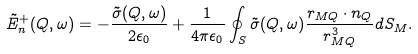Convert formula to latex. <formula><loc_0><loc_0><loc_500><loc_500>\tilde { E } _ { n } ^ { + } ( Q , \omega ) = - \frac { \tilde { \sigma } ( Q , \omega ) } { 2 \epsilon _ { 0 } } + \frac { 1 } { 4 \pi \epsilon _ { 0 } } \oint _ { S } \tilde { \sigma } ( Q , \omega ) \frac { r _ { M Q } \cdot n _ { Q } } { r _ { M Q } ^ { 3 } } d S _ { M } .</formula> 